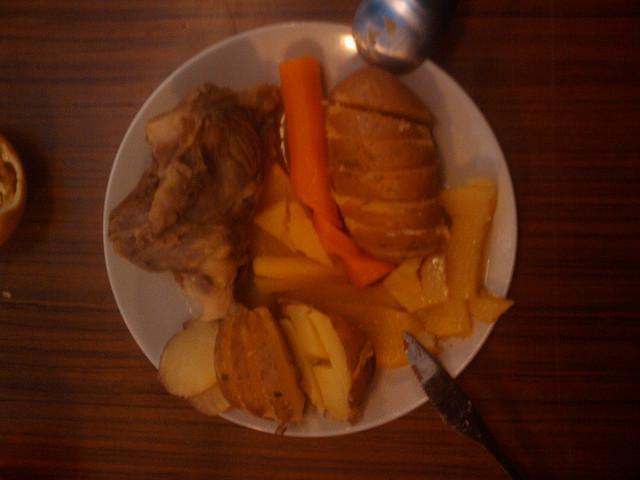What kind of vegetable is between the bread and the meat on top of the white plate?
Choose the right answer from the provided options to respond to the question.
Options: Red, purple, orange, green. Orange. 